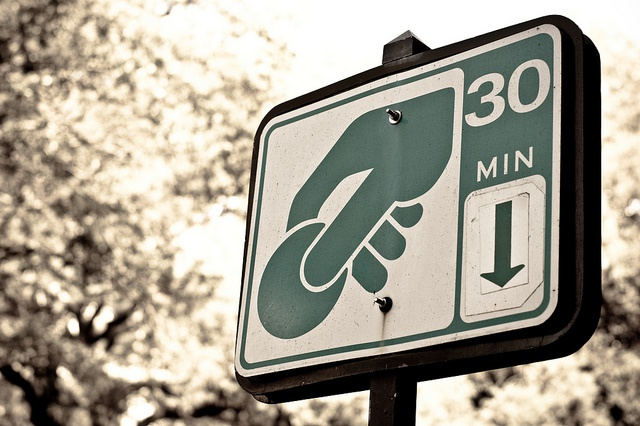Describe the objects in this image and their specific colors. I can see various objects in this image with different colors. 